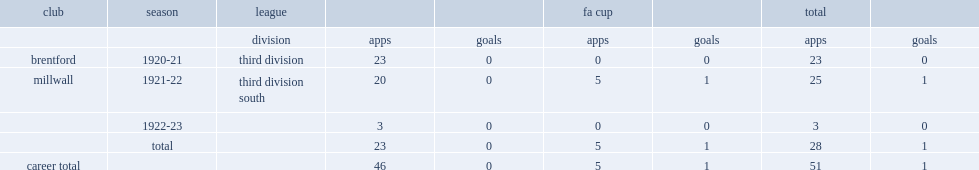Which club did taylor play for in 1920-21? Brentford. 